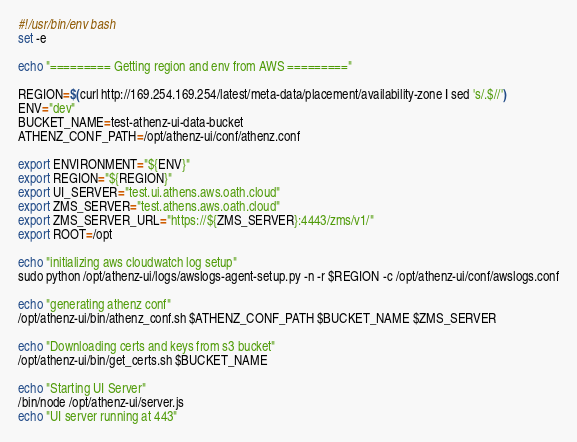<code> <loc_0><loc_0><loc_500><loc_500><_Bash_>#!/usr/bin/env bash
set -e

echo "========= Getting region and env from AWS ========="

REGION=$(curl http://169.254.169.254/latest/meta-data/placement/availability-zone | sed 's/.$//')
ENV="dev"
BUCKET_NAME=test-athenz-ui-data-bucket
ATHENZ_CONF_PATH=/opt/athenz-ui/conf/athenz.conf

export ENVIRONMENT="${ENV}"
export REGION="${REGION}"
export UI_SERVER="test.ui.athens.aws.oath.cloud"
export ZMS_SERVER="test.athens.aws.oath.cloud"
export ZMS_SERVER_URL="https://${ZMS_SERVER}:4443/zms/v1/"
export ROOT=/opt

echo "initializing aws cloudwatch log setup"
sudo python /opt/athenz-ui/logs/awslogs-agent-setup.py -n -r $REGION -c /opt/athenz-ui/conf/awslogs.conf

echo "generating athenz conf"
/opt/athenz-ui/bin/athenz_conf.sh $ATHENZ_CONF_PATH $BUCKET_NAME $ZMS_SERVER

echo "Downloading certs and keys from s3 bucket"
/opt/athenz-ui/bin/get_certs.sh $BUCKET_NAME

echo "Starting UI Server"
/bin/node /opt/athenz-ui/server.js
echo "UI server running at 443"</code> 